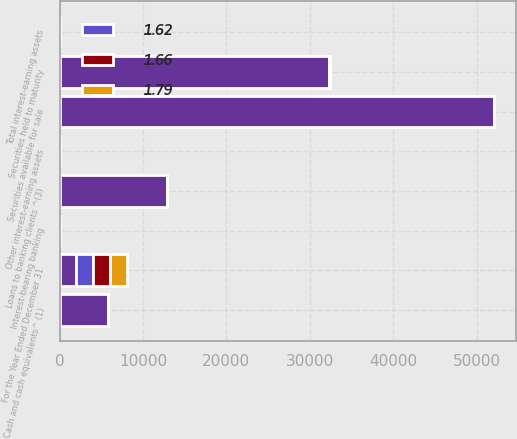<chart> <loc_0><loc_0><loc_500><loc_500><stacked_bar_chart><ecel><fcel>For the Year Ended December 31<fcel>Cash and cash equivalents^ (1)<fcel>Securities available for sale<fcel>Securities held to maturity<fcel>Loans to banking clients ^(3)<fcel>Other interest-earning assets<fcel>Total interest-earning assets<fcel>Interest-bearing banking<nl><fcel>nan<fcel>2014<fcel>5871<fcel>52056<fcel>32361<fcel>12903<fcel>63<fcel>2.57<fcel>2.57<nl><fcel>1.66<fcel>2014<fcel>0.26<fcel>1.05<fcel>2.56<fcel>2.74<fcel>9.52<fcel>1.69<fcel>0.03<nl><fcel>1.79<fcel>2013<fcel>0.27<fcel>1.13<fcel>2.45<fcel>2.8<fcel>3.77<fcel>1.65<fcel>0.04<nl><fcel>1.62<fcel>2012<fcel>0.27<fcel>1.47<fcel>2.58<fcel>3.07<fcel>1.85<fcel>1.84<fcel>0.06<nl></chart> 